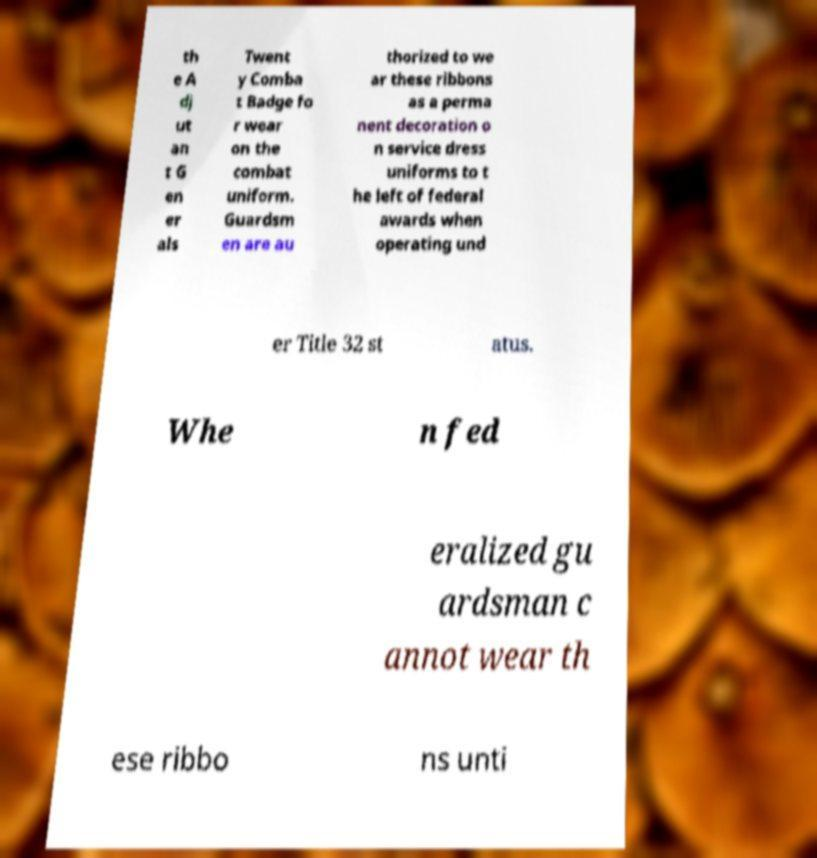Please identify and transcribe the text found in this image. th e A dj ut an t G en er als Twent y Comba t Badge fo r wear on the combat uniform. Guardsm en are au thorized to we ar these ribbons as a perma nent decoration o n service dress uniforms to t he left of federal awards when operating und er Title 32 st atus. Whe n fed eralized gu ardsman c annot wear th ese ribbo ns unti 